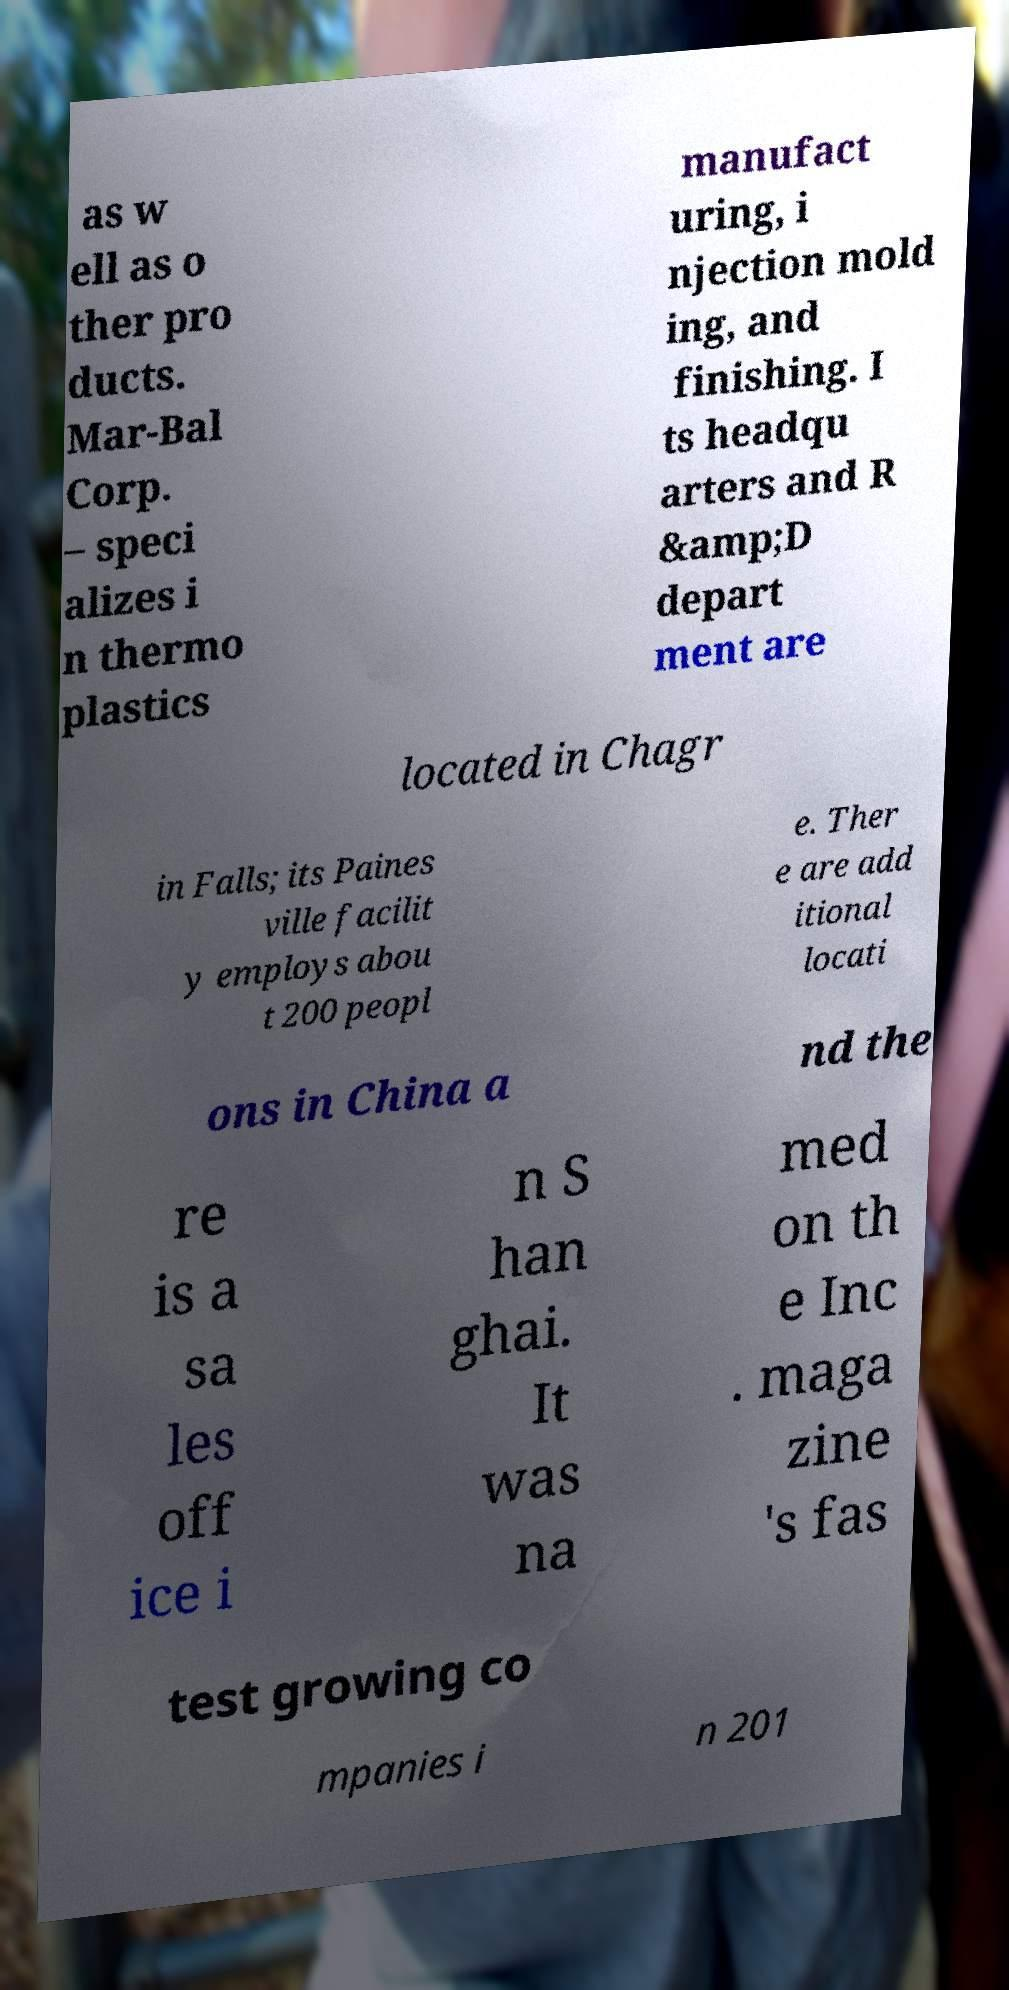Could you assist in decoding the text presented in this image and type it out clearly? as w ell as o ther pro ducts. Mar-Bal Corp. – speci alizes i n thermo plastics manufact uring, i njection mold ing, and finishing. I ts headqu arters and R &amp;D depart ment are located in Chagr in Falls; its Paines ville facilit y employs abou t 200 peopl e. Ther e are add itional locati ons in China a nd the re is a sa les off ice i n S han ghai. It was na med on th e Inc . maga zine 's fas test growing co mpanies i n 201 